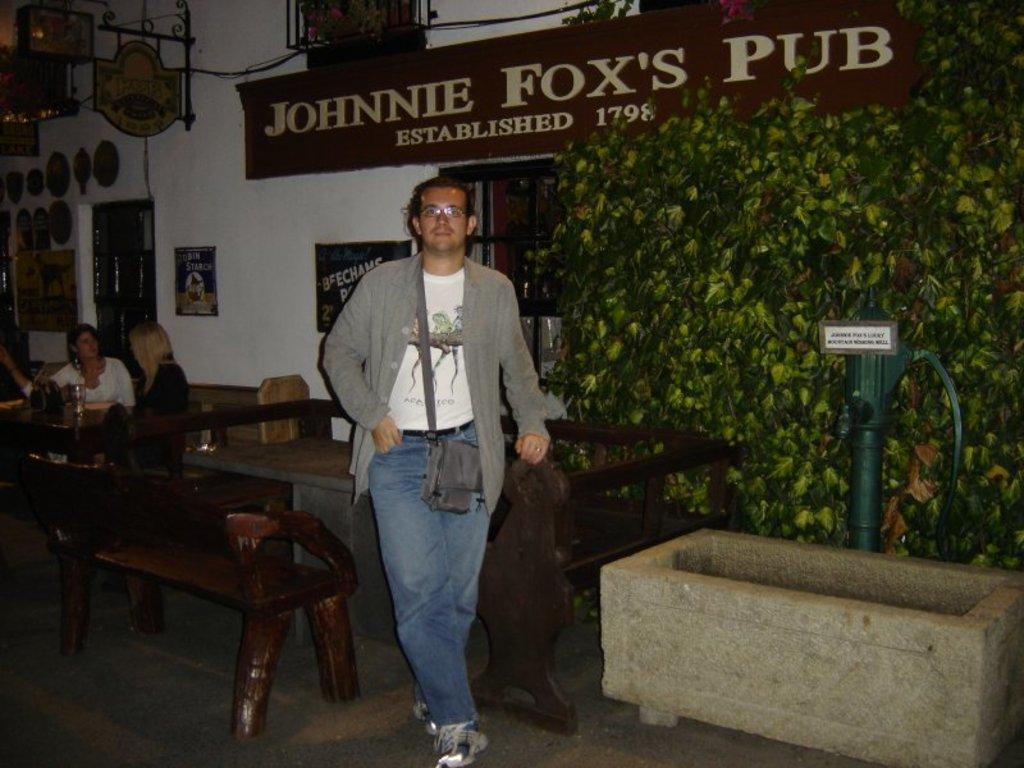What is the main subject in the image? There is a man standing in the image. What else can be seen in the image besides the man? There is a plant and a name board on the wall in the image. Are there any other people in the image? Yes, there are people sitting in the image. What type of loaf is being discovered by the man in the image? There is no loaf present in the image, and the man is not discovering anything. 